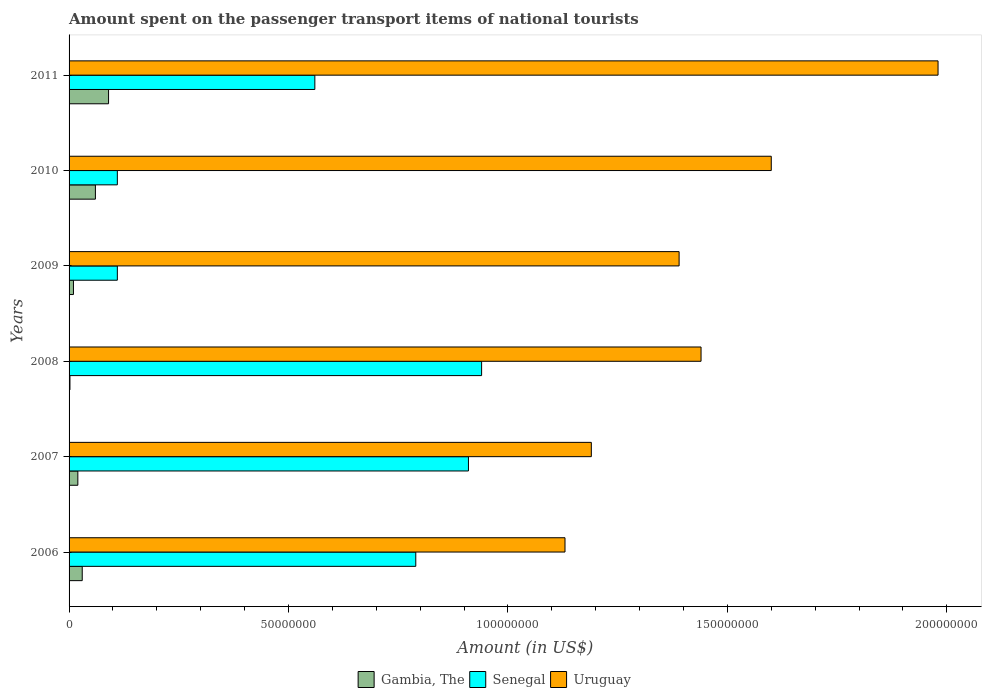How many groups of bars are there?
Give a very brief answer. 6. How many bars are there on the 1st tick from the bottom?
Keep it short and to the point. 3. What is the amount spent on the passenger transport items of national tourists in Uruguay in 2006?
Ensure brevity in your answer.  1.13e+08. Across all years, what is the maximum amount spent on the passenger transport items of national tourists in Senegal?
Provide a succinct answer. 9.40e+07. Across all years, what is the minimum amount spent on the passenger transport items of national tourists in Senegal?
Offer a very short reply. 1.10e+07. In which year was the amount spent on the passenger transport items of national tourists in Senegal minimum?
Your answer should be compact. 2009. What is the total amount spent on the passenger transport items of national tourists in Uruguay in the graph?
Make the answer very short. 8.73e+08. What is the difference between the amount spent on the passenger transport items of national tourists in Uruguay in 2007 and that in 2010?
Give a very brief answer. -4.10e+07. What is the difference between the amount spent on the passenger transport items of national tourists in Gambia, The in 2010 and the amount spent on the passenger transport items of national tourists in Senegal in 2006?
Ensure brevity in your answer.  -7.30e+07. What is the average amount spent on the passenger transport items of national tourists in Senegal per year?
Your response must be concise. 5.70e+07. In the year 2009, what is the difference between the amount spent on the passenger transport items of national tourists in Senegal and amount spent on the passenger transport items of national tourists in Gambia, The?
Make the answer very short. 1.00e+07. In how many years, is the amount spent on the passenger transport items of national tourists in Senegal greater than 180000000 US$?
Your answer should be compact. 0. What is the ratio of the amount spent on the passenger transport items of national tourists in Senegal in 2006 to that in 2011?
Keep it short and to the point. 1.41. Is the amount spent on the passenger transport items of national tourists in Senegal in 2007 less than that in 2011?
Your answer should be compact. No. What is the difference between the highest and the second highest amount spent on the passenger transport items of national tourists in Senegal?
Offer a very short reply. 3.00e+06. What is the difference between the highest and the lowest amount spent on the passenger transport items of national tourists in Uruguay?
Your response must be concise. 8.50e+07. Is the sum of the amount spent on the passenger transport items of national tourists in Senegal in 2010 and 2011 greater than the maximum amount spent on the passenger transport items of national tourists in Gambia, The across all years?
Your answer should be very brief. Yes. What does the 2nd bar from the top in 2009 represents?
Keep it short and to the point. Senegal. What does the 3rd bar from the bottom in 2010 represents?
Your answer should be very brief. Uruguay. Are the values on the major ticks of X-axis written in scientific E-notation?
Ensure brevity in your answer.  No. Does the graph contain grids?
Offer a very short reply. No. How are the legend labels stacked?
Make the answer very short. Horizontal. What is the title of the graph?
Your answer should be very brief. Amount spent on the passenger transport items of national tourists. Does "Brunei Darussalam" appear as one of the legend labels in the graph?
Provide a succinct answer. No. What is the label or title of the Y-axis?
Provide a succinct answer. Years. What is the Amount (in US$) in Gambia, The in 2006?
Keep it short and to the point. 3.00e+06. What is the Amount (in US$) in Senegal in 2006?
Provide a succinct answer. 7.90e+07. What is the Amount (in US$) of Uruguay in 2006?
Your answer should be very brief. 1.13e+08. What is the Amount (in US$) in Gambia, The in 2007?
Offer a terse response. 2.00e+06. What is the Amount (in US$) in Senegal in 2007?
Make the answer very short. 9.10e+07. What is the Amount (in US$) in Uruguay in 2007?
Ensure brevity in your answer.  1.19e+08. What is the Amount (in US$) of Senegal in 2008?
Ensure brevity in your answer.  9.40e+07. What is the Amount (in US$) in Uruguay in 2008?
Your answer should be compact. 1.44e+08. What is the Amount (in US$) in Senegal in 2009?
Your response must be concise. 1.10e+07. What is the Amount (in US$) of Uruguay in 2009?
Make the answer very short. 1.39e+08. What is the Amount (in US$) in Senegal in 2010?
Ensure brevity in your answer.  1.10e+07. What is the Amount (in US$) in Uruguay in 2010?
Give a very brief answer. 1.60e+08. What is the Amount (in US$) of Gambia, The in 2011?
Offer a terse response. 9.00e+06. What is the Amount (in US$) of Senegal in 2011?
Provide a succinct answer. 5.60e+07. What is the Amount (in US$) in Uruguay in 2011?
Make the answer very short. 1.98e+08. Across all years, what is the maximum Amount (in US$) in Gambia, The?
Your response must be concise. 9.00e+06. Across all years, what is the maximum Amount (in US$) of Senegal?
Make the answer very short. 9.40e+07. Across all years, what is the maximum Amount (in US$) of Uruguay?
Ensure brevity in your answer.  1.98e+08. Across all years, what is the minimum Amount (in US$) in Gambia, The?
Keep it short and to the point. 2.00e+05. Across all years, what is the minimum Amount (in US$) of Senegal?
Provide a succinct answer. 1.10e+07. Across all years, what is the minimum Amount (in US$) of Uruguay?
Ensure brevity in your answer.  1.13e+08. What is the total Amount (in US$) in Gambia, The in the graph?
Ensure brevity in your answer.  2.12e+07. What is the total Amount (in US$) in Senegal in the graph?
Provide a short and direct response. 3.42e+08. What is the total Amount (in US$) of Uruguay in the graph?
Ensure brevity in your answer.  8.73e+08. What is the difference between the Amount (in US$) in Senegal in 2006 and that in 2007?
Offer a very short reply. -1.20e+07. What is the difference between the Amount (in US$) in Uruguay in 2006 and that in 2007?
Offer a terse response. -6.00e+06. What is the difference between the Amount (in US$) of Gambia, The in 2006 and that in 2008?
Give a very brief answer. 2.80e+06. What is the difference between the Amount (in US$) in Senegal in 2006 and that in 2008?
Your response must be concise. -1.50e+07. What is the difference between the Amount (in US$) in Uruguay in 2006 and that in 2008?
Offer a terse response. -3.10e+07. What is the difference between the Amount (in US$) in Gambia, The in 2006 and that in 2009?
Your answer should be very brief. 2.00e+06. What is the difference between the Amount (in US$) of Senegal in 2006 and that in 2009?
Ensure brevity in your answer.  6.80e+07. What is the difference between the Amount (in US$) of Uruguay in 2006 and that in 2009?
Ensure brevity in your answer.  -2.60e+07. What is the difference between the Amount (in US$) in Gambia, The in 2006 and that in 2010?
Ensure brevity in your answer.  -3.00e+06. What is the difference between the Amount (in US$) of Senegal in 2006 and that in 2010?
Provide a short and direct response. 6.80e+07. What is the difference between the Amount (in US$) in Uruguay in 2006 and that in 2010?
Provide a succinct answer. -4.70e+07. What is the difference between the Amount (in US$) of Gambia, The in 2006 and that in 2011?
Offer a very short reply. -6.00e+06. What is the difference between the Amount (in US$) of Senegal in 2006 and that in 2011?
Ensure brevity in your answer.  2.30e+07. What is the difference between the Amount (in US$) of Uruguay in 2006 and that in 2011?
Ensure brevity in your answer.  -8.50e+07. What is the difference between the Amount (in US$) in Gambia, The in 2007 and that in 2008?
Keep it short and to the point. 1.80e+06. What is the difference between the Amount (in US$) in Uruguay in 2007 and that in 2008?
Your answer should be very brief. -2.50e+07. What is the difference between the Amount (in US$) of Gambia, The in 2007 and that in 2009?
Provide a succinct answer. 1.00e+06. What is the difference between the Amount (in US$) in Senegal in 2007 and that in 2009?
Your answer should be very brief. 8.00e+07. What is the difference between the Amount (in US$) of Uruguay in 2007 and that in 2009?
Provide a short and direct response. -2.00e+07. What is the difference between the Amount (in US$) of Gambia, The in 2007 and that in 2010?
Provide a succinct answer. -4.00e+06. What is the difference between the Amount (in US$) of Senegal in 2007 and that in 2010?
Provide a short and direct response. 8.00e+07. What is the difference between the Amount (in US$) of Uruguay in 2007 and that in 2010?
Your answer should be compact. -4.10e+07. What is the difference between the Amount (in US$) in Gambia, The in 2007 and that in 2011?
Offer a very short reply. -7.00e+06. What is the difference between the Amount (in US$) in Senegal in 2007 and that in 2011?
Your answer should be compact. 3.50e+07. What is the difference between the Amount (in US$) of Uruguay in 2007 and that in 2011?
Offer a very short reply. -7.90e+07. What is the difference between the Amount (in US$) of Gambia, The in 2008 and that in 2009?
Your answer should be very brief. -8.00e+05. What is the difference between the Amount (in US$) in Senegal in 2008 and that in 2009?
Offer a terse response. 8.30e+07. What is the difference between the Amount (in US$) of Uruguay in 2008 and that in 2009?
Provide a short and direct response. 5.00e+06. What is the difference between the Amount (in US$) in Gambia, The in 2008 and that in 2010?
Offer a very short reply. -5.80e+06. What is the difference between the Amount (in US$) in Senegal in 2008 and that in 2010?
Provide a succinct answer. 8.30e+07. What is the difference between the Amount (in US$) of Uruguay in 2008 and that in 2010?
Keep it short and to the point. -1.60e+07. What is the difference between the Amount (in US$) of Gambia, The in 2008 and that in 2011?
Ensure brevity in your answer.  -8.80e+06. What is the difference between the Amount (in US$) in Senegal in 2008 and that in 2011?
Your answer should be compact. 3.80e+07. What is the difference between the Amount (in US$) of Uruguay in 2008 and that in 2011?
Provide a succinct answer. -5.40e+07. What is the difference between the Amount (in US$) in Gambia, The in 2009 and that in 2010?
Give a very brief answer. -5.00e+06. What is the difference between the Amount (in US$) of Uruguay in 2009 and that in 2010?
Your answer should be very brief. -2.10e+07. What is the difference between the Amount (in US$) in Gambia, The in 2009 and that in 2011?
Keep it short and to the point. -8.00e+06. What is the difference between the Amount (in US$) of Senegal in 2009 and that in 2011?
Give a very brief answer. -4.50e+07. What is the difference between the Amount (in US$) in Uruguay in 2009 and that in 2011?
Provide a short and direct response. -5.90e+07. What is the difference between the Amount (in US$) of Gambia, The in 2010 and that in 2011?
Provide a succinct answer. -3.00e+06. What is the difference between the Amount (in US$) in Senegal in 2010 and that in 2011?
Give a very brief answer. -4.50e+07. What is the difference between the Amount (in US$) of Uruguay in 2010 and that in 2011?
Give a very brief answer. -3.80e+07. What is the difference between the Amount (in US$) in Gambia, The in 2006 and the Amount (in US$) in Senegal in 2007?
Ensure brevity in your answer.  -8.80e+07. What is the difference between the Amount (in US$) in Gambia, The in 2006 and the Amount (in US$) in Uruguay in 2007?
Ensure brevity in your answer.  -1.16e+08. What is the difference between the Amount (in US$) of Senegal in 2006 and the Amount (in US$) of Uruguay in 2007?
Make the answer very short. -4.00e+07. What is the difference between the Amount (in US$) of Gambia, The in 2006 and the Amount (in US$) of Senegal in 2008?
Make the answer very short. -9.10e+07. What is the difference between the Amount (in US$) in Gambia, The in 2006 and the Amount (in US$) in Uruguay in 2008?
Offer a very short reply. -1.41e+08. What is the difference between the Amount (in US$) in Senegal in 2006 and the Amount (in US$) in Uruguay in 2008?
Offer a very short reply. -6.50e+07. What is the difference between the Amount (in US$) in Gambia, The in 2006 and the Amount (in US$) in Senegal in 2009?
Ensure brevity in your answer.  -8.00e+06. What is the difference between the Amount (in US$) in Gambia, The in 2006 and the Amount (in US$) in Uruguay in 2009?
Offer a very short reply. -1.36e+08. What is the difference between the Amount (in US$) in Senegal in 2006 and the Amount (in US$) in Uruguay in 2009?
Provide a succinct answer. -6.00e+07. What is the difference between the Amount (in US$) of Gambia, The in 2006 and the Amount (in US$) of Senegal in 2010?
Ensure brevity in your answer.  -8.00e+06. What is the difference between the Amount (in US$) of Gambia, The in 2006 and the Amount (in US$) of Uruguay in 2010?
Keep it short and to the point. -1.57e+08. What is the difference between the Amount (in US$) in Senegal in 2006 and the Amount (in US$) in Uruguay in 2010?
Provide a short and direct response. -8.10e+07. What is the difference between the Amount (in US$) in Gambia, The in 2006 and the Amount (in US$) in Senegal in 2011?
Your response must be concise. -5.30e+07. What is the difference between the Amount (in US$) of Gambia, The in 2006 and the Amount (in US$) of Uruguay in 2011?
Keep it short and to the point. -1.95e+08. What is the difference between the Amount (in US$) in Senegal in 2006 and the Amount (in US$) in Uruguay in 2011?
Give a very brief answer. -1.19e+08. What is the difference between the Amount (in US$) in Gambia, The in 2007 and the Amount (in US$) in Senegal in 2008?
Offer a very short reply. -9.20e+07. What is the difference between the Amount (in US$) in Gambia, The in 2007 and the Amount (in US$) in Uruguay in 2008?
Your answer should be very brief. -1.42e+08. What is the difference between the Amount (in US$) of Senegal in 2007 and the Amount (in US$) of Uruguay in 2008?
Give a very brief answer. -5.30e+07. What is the difference between the Amount (in US$) in Gambia, The in 2007 and the Amount (in US$) in Senegal in 2009?
Your answer should be compact. -9.00e+06. What is the difference between the Amount (in US$) in Gambia, The in 2007 and the Amount (in US$) in Uruguay in 2009?
Keep it short and to the point. -1.37e+08. What is the difference between the Amount (in US$) in Senegal in 2007 and the Amount (in US$) in Uruguay in 2009?
Offer a very short reply. -4.80e+07. What is the difference between the Amount (in US$) in Gambia, The in 2007 and the Amount (in US$) in Senegal in 2010?
Make the answer very short. -9.00e+06. What is the difference between the Amount (in US$) of Gambia, The in 2007 and the Amount (in US$) of Uruguay in 2010?
Keep it short and to the point. -1.58e+08. What is the difference between the Amount (in US$) in Senegal in 2007 and the Amount (in US$) in Uruguay in 2010?
Your response must be concise. -6.90e+07. What is the difference between the Amount (in US$) of Gambia, The in 2007 and the Amount (in US$) of Senegal in 2011?
Provide a succinct answer. -5.40e+07. What is the difference between the Amount (in US$) in Gambia, The in 2007 and the Amount (in US$) in Uruguay in 2011?
Your answer should be compact. -1.96e+08. What is the difference between the Amount (in US$) of Senegal in 2007 and the Amount (in US$) of Uruguay in 2011?
Your answer should be compact. -1.07e+08. What is the difference between the Amount (in US$) of Gambia, The in 2008 and the Amount (in US$) of Senegal in 2009?
Your answer should be compact. -1.08e+07. What is the difference between the Amount (in US$) of Gambia, The in 2008 and the Amount (in US$) of Uruguay in 2009?
Your response must be concise. -1.39e+08. What is the difference between the Amount (in US$) of Senegal in 2008 and the Amount (in US$) of Uruguay in 2009?
Your answer should be compact. -4.50e+07. What is the difference between the Amount (in US$) of Gambia, The in 2008 and the Amount (in US$) of Senegal in 2010?
Offer a terse response. -1.08e+07. What is the difference between the Amount (in US$) in Gambia, The in 2008 and the Amount (in US$) in Uruguay in 2010?
Your answer should be compact. -1.60e+08. What is the difference between the Amount (in US$) in Senegal in 2008 and the Amount (in US$) in Uruguay in 2010?
Provide a succinct answer. -6.60e+07. What is the difference between the Amount (in US$) of Gambia, The in 2008 and the Amount (in US$) of Senegal in 2011?
Provide a short and direct response. -5.58e+07. What is the difference between the Amount (in US$) in Gambia, The in 2008 and the Amount (in US$) in Uruguay in 2011?
Keep it short and to the point. -1.98e+08. What is the difference between the Amount (in US$) of Senegal in 2008 and the Amount (in US$) of Uruguay in 2011?
Your answer should be compact. -1.04e+08. What is the difference between the Amount (in US$) of Gambia, The in 2009 and the Amount (in US$) of Senegal in 2010?
Offer a very short reply. -1.00e+07. What is the difference between the Amount (in US$) of Gambia, The in 2009 and the Amount (in US$) of Uruguay in 2010?
Your answer should be compact. -1.59e+08. What is the difference between the Amount (in US$) of Senegal in 2009 and the Amount (in US$) of Uruguay in 2010?
Your response must be concise. -1.49e+08. What is the difference between the Amount (in US$) of Gambia, The in 2009 and the Amount (in US$) of Senegal in 2011?
Make the answer very short. -5.50e+07. What is the difference between the Amount (in US$) of Gambia, The in 2009 and the Amount (in US$) of Uruguay in 2011?
Provide a short and direct response. -1.97e+08. What is the difference between the Amount (in US$) in Senegal in 2009 and the Amount (in US$) in Uruguay in 2011?
Make the answer very short. -1.87e+08. What is the difference between the Amount (in US$) of Gambia, The in 2010 and the Amount (in US$) of Senegal in 2011?
Your answer should be very brief. -5.00e+07. What is the difference between the Amount (in US$) in Gambia, The in 2010 and the Amount (in US$) in Uruguay in 2011?
Offer a very short reply. -1.92e+08. What is the difference between the Amount (in US$) of Senegal in 2010 and the Amount (in US$) of Uruguay in 2011?
Provide a short and direct response. -1.87e+08. What is the average Amount (in US$) in Gambia, The per year?
Offer a very short reply. 3.53e+06. What is the average Amount (in US$) of Senegal per year?
Your answer should be very brief. 5.70e+07. What is the average Amount (in US$) of Uruguay per year?
Provide a short and direct response. 1.46e+08. In the year 2006, what is the difference between the Amount (in US$) of Gambia, The and Amount (in US$) of Senegal?
Offer a terse response. -7.60e+07. In the year 2006, what is the difference between the Amount (in US$) in Gambia, The and Amount (in US$) in Uruguay?
Make the answer very short. -1.10e+08. In the year 2006, what is the difference between the Amount (in US$) in Senegal and Amount (in US$) in Uruguay?
Give a very brief answer. -3.40e+07. In the year 2007, what is the difference between the Amount (in US$) in Gambia, The and Amount (in US$) in Senegal?
Your response must be concise. -8.90e+07. In the year 2007, what is the difference between the Amount (in US$) of Gambia, The and Amount (in US$) of Uruguay?
Your response must be concise. -1.17e+08. In the year 2007, what is the difference between the Amount (in US$) of Senegal and Amount (in US$) of Uruguay?
Provide a succinct answer. -2.80e+07. In the year 2008, what is the difference between the Amount (in US$) of Gambia, The and Amount (in US$) of Senegal?
Your answer should be compact. -9.38e+07. In the year 2008, what is the difference between the Amount (in US$) of Gambia, The and Amount (in US$) of Uruguay?
Your answer should be compact. -1.44e+08. In the year 2008, what is the difference between the Amount (in US$) of Senegal and Amount (in US$) of Uruguay?
Provide a short and direct response. -5.00e+07. In the year 2009, what is the difference between the Amount (in US$) of Gambia, The and Amount (in US$) of Senegal?
Provide a succinct answer. -1.00e+07. In the year 2009, what is the difference between the Amount (in US$) in Gambia, The and Amount (in US$) in Uruguay?
Keep it short and to the point. -1.38e+08. In the year 2009, what is the difference between the Amount (in US$) in Senegal and Amount (in US$) in Uruguay?
Offer a terse response. -1.28e+08. In the year 2010, what is the difference between the Amount (in US$) of Gambia, The and Amount (in US$) of Senegal?
Provide a succinct answer. -5.00e+06. In the year 2010, what is the difference between the Amount (in US$) in Gambia, The and Amount (in US$) in Uruguay?
Provide a succinct answer. -1.54e+08. In the year 2010, what is the difference between the Amount (in US$) in Senegal and Amount (in US$) in Uruguay?
Offer a terse response. -1.49e+08. In the year 2011, what is the difference between the Amount (in US$) of Gambia, The and Amount (in US$) of Senegal?
Ensure brevity in your answer.  -4.70e+07. In the year 2011, what is the difference between the Amount (in US$) of Gambia, The and Amount (in US$) of Uruguay?
Provide a succinct answer. -1.89e+08. In the year 2011, what is the difference between the Amount (in US$) of Senegal and Amount (in US$) of Uruguay?
Your response must be concise. -1.42e+08. What is the ratio of the Amount (in US$) in Gambia, The in 2006 to that in 2007?
Offer a very short reply. 1.5. What is the ratio of the Amount (in US$) in Senegal in 2006 to that in 2007?
Offer a very short reply. 0.87. What is the ratio of the Amount (in US$) in Uruguay in 2006 to that in 2007?
Your answer should be very brief. 0.95. What is the ratio of the Amount (in US$) in Senegal in 2006 to that in 2008?
Offer a very short reply. 0.84. What is the ratio of the Amount (in US$) of Uruguay in 2006 to that in 2008?
Provide a succinct answer. 0.78. What is the ratio of the Amount (in US$) of Gambia, The in 2006 to that in 2009?
Ensure brevity in your answer.  3. What is the ratio of the Amount (in US$) of Senegal in 2006 to that in 2009?
Keep it short and to the point. 7.18. What is the ratio of the Amount (in US$) in Uruguay in 2006 to that in 2009?
Provide a short and direct response. 0.81. What is the ratio of the Amount (in US$) of Gambia, The in 2006 to that in 2010?
Your answer should be compact. 0.5. What is the ratio of the Amount (in US$) in Senegal in 2006 to that in 2010?
Keep it short and to the point. 7.18. What is the ratio of the Amount (in US$) of Uruguay in 2006 to that in 2010?
Your answer should be compact. 0.71. What is the ratio of the Amount (in US$) in Senegal in 2006 to that in 2011?
Make the answer very short. 1.41. What is the ratio of the Amount (in US$) of Uruguay in 2006 to that in 2011?
Offer a very short reply. 0.57. What is the ratio of the Amount (in US$) in Senegal in 2007 to that in 2008?
Offer a very short reply. 0.97. What is the ratio of the Amount (in US$) of Uruguay in 2007 to that in 2008?
Provide a succinct answer. 0.83. What is the ratio of the Amount (in US$) in Gambia, The in 2007 to that in 2009?
Provide a succinct answer. 2. What is the ratio of the Amount (in US$) in Senegal in 2007 to that in 2009?
Make the answer very short. 8.27. What is the ratio of the Amount (in US$) of Uruguay in 2007 to that in 2009?
Your answer should be compact. 0.86. What is the ratio of the Amount (in US$) of Gambia, The in 2007 to that in 2010?
Provide a short and direct response. 0.33. What is the ratio of the Amount (in US$) in Senegal in 2007 to that in 2010?
Make the answer very short. 8.27. What is the ratio of the Amount (in US$) in Uruguay in 2007 to that in 2010?
Your response must be concise. 0.74. What is the ratio of the Amount (in US$) in Gambia, The in 2007 to that in 2011?
Make the answer very short. 0.22. What is the ratio of the Amount (in US$) in Senegal in 2007 to that in 2011?
Give a very brief answer. 1.62. What is the ratio of the Amount (in US$) of Uruguay in 2007 to that in 2011?
Give a very brief answer. 0.6. What is the ratio of the Amount (in US$) of Senegal in 2008 to that in 2009?
Your answer should be compact. 8.55. What is the ratio of the Amount (in US$) of Uruguay in 2008 to that in 2009?
Make the answer very short. 1.04. What is the ratio of the Amount (in US$) of Gambia, The in 2008 to that in 2010?
Your response must be concise. 0.03. What is the ratio of the Amount (in US$) of Senegal in 2008 to that in 2010?
Provide a short and direct response. 8.55. What is the ratio of the Amount (in US$) of Uruguay in 2008 to that in 2010?
Offer a terse response. 0.9. What is the ratio of the Amount (in US$) in Gambia, The in 2008 to that in 2011?
Keep it short and to the point. 0.02. What is the ratio of the Amount (in US$) in Senegal in 2008 to that in 2011?
Your answer should be very brief. 1.68. What is the ratio of the Amount (in US$) of Uruguay in 2008 to that in 2011?
Make the answer very short. 0.73. What is the ratio of the Amount (in US$) of Senegal in 2009 to that in 2010?
Offer a very short reply. 1. What is the ratio of the Amount (in US$) of Uruguay in 2009 to that in 2010?
Provide a succinct answer. 0.87. What is the ratio of the Amount (in US$) of Senegal in 2009 to that in 2011?
Make the answer very short. 0.2. What is the ratio of the Amount (in US$) of Uruguay in 2009 to that in 2011?
Keep it short and to the point. 0.7. What is the ratio of the Amount (in US$) of Gambia, The in 2010 to that in 2011?
Give a very brief answer. 0.67. What is the ratio of the Amount (in US$) of Senegal in 2010 to that in 2011?
Give a very brief answer. 0.2. What is the ratio of the Amount (in US$) of Uruguay in 2010 to that in 2011?
Provide a short and direct response. 0.81. What is the difference between the highest and the second highest Amount (in US$) of Senegal?
Your response must be concise. 3.00e+06. What is the difference between the highest and the second highest Amount (in US$) of Uruguay?
Provide a succinct answer. 3.80e+07. What is the difference between the highest and the lowest Amount (in US$) in Gambia, The?
Keep it short and to the point. 8.80e+06. What is the difference between the highest and the lowest Amount (in US$) in Senegal?
Provide a succinct answer. 8.30e+07. What is the difference between the highest and the lowest Amount (in US$) of Uruguay?
Give a very brief answer. 8.50e+07. 